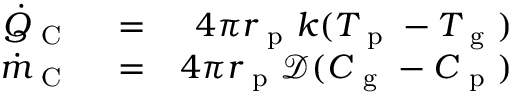Convert formula to latex. <formula><loc_0><loc_0><loc_500><loc_500>\begin{array} { r l r } { \dot { Q } _ { C } } & = } & { 4 \pi r _ { p } k ( T _ { p } - T _ { g } ) } \\ { \dot { m } _ { C } } & = } & { 4 \pi r _ { p } \mathcal { D } ( C _ { g } - C _ { p } ) } \end{array}</formula> 